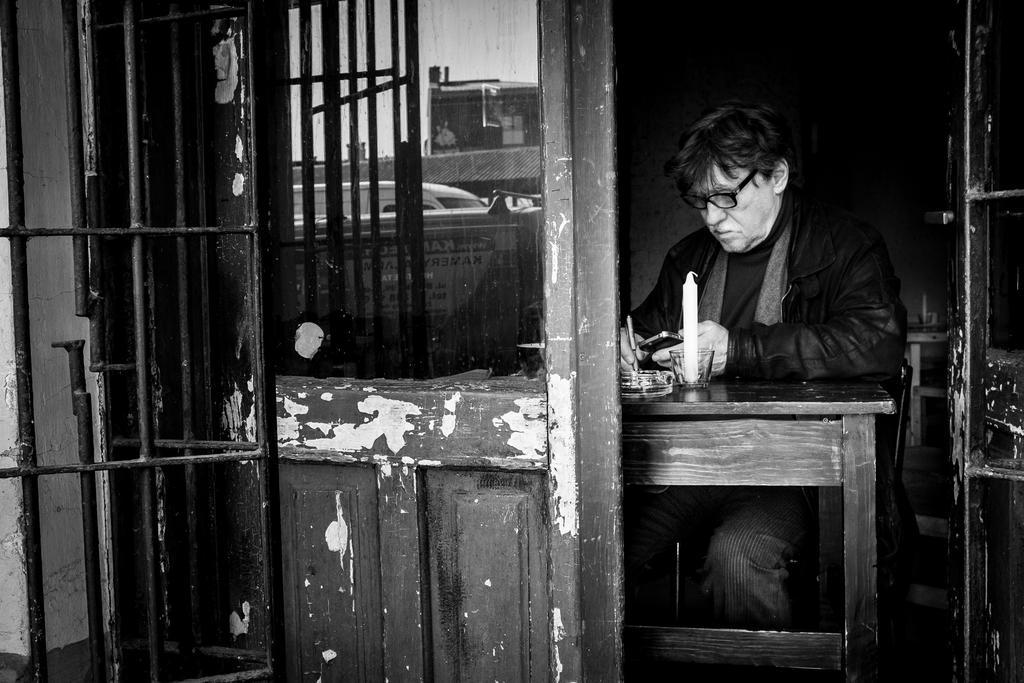Can you describe this image briefly? In this picture we can see a man is sitting in front of a table, he is holding a mobile phone and writing something, we can see a candle on the table, on the left side there is a door and grilles, we can see reflection of a vehicle on this glass, it is a black and white image, in the background there is a wall. 